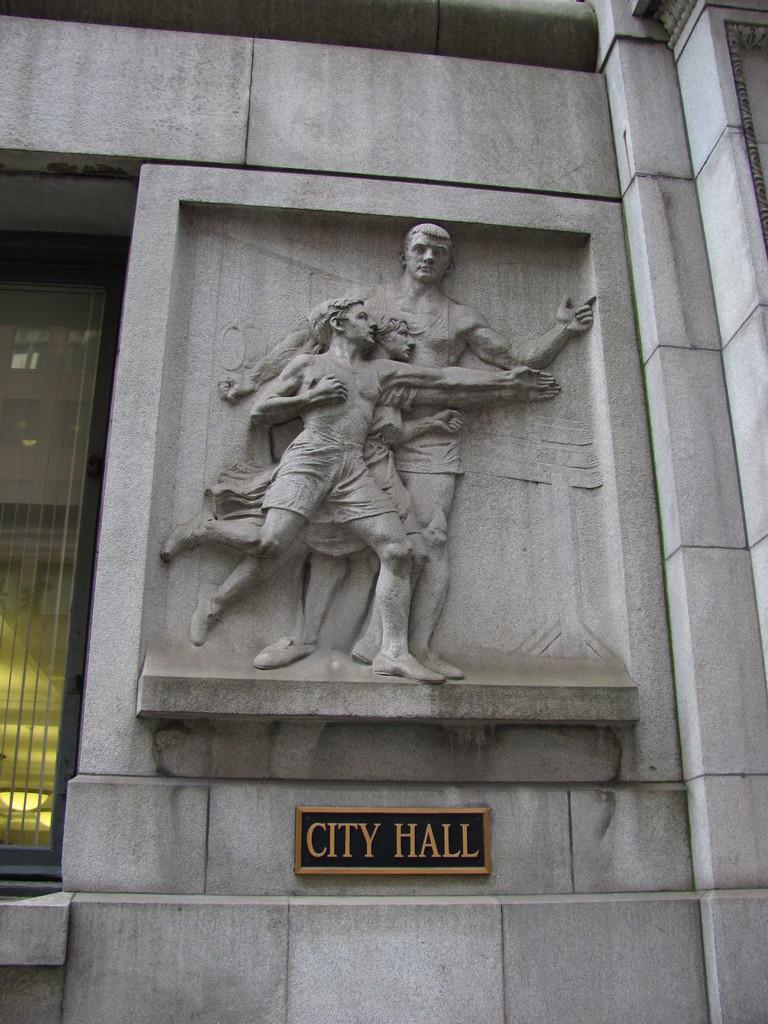Please provide a concise description of this image. In this image I can see a sculpture on the wall. Under the sculpture there is a name board attached to the wall. On the left side there is a glass. 